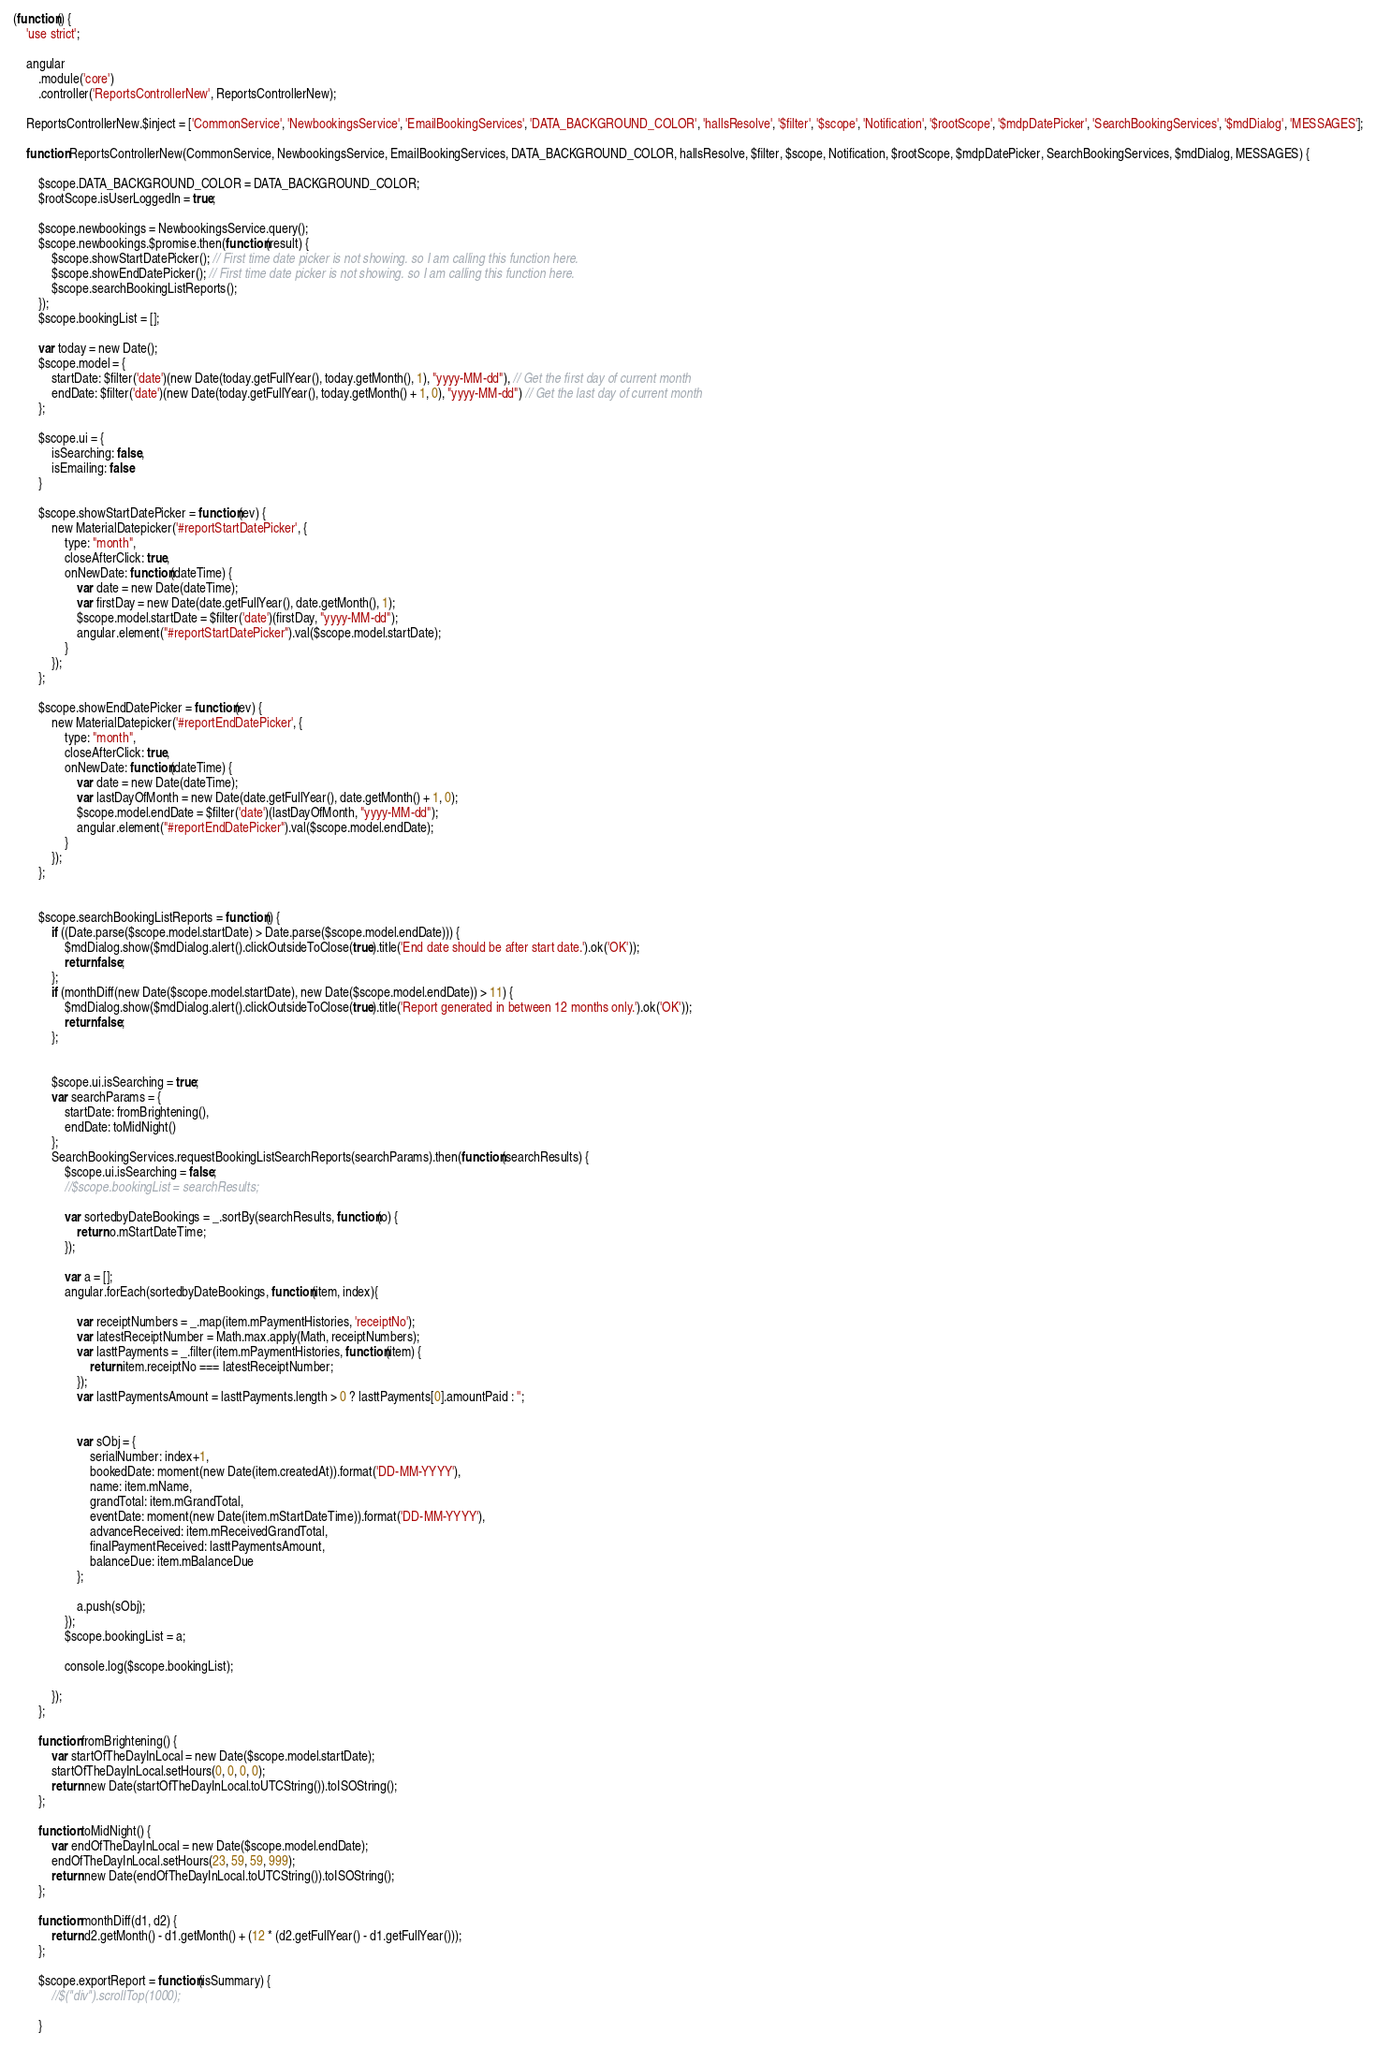<code> <loc_0><loc_0><loc_500><loc_500><_JavaScript_>(function() {
	'use strict';

	angular
		.module('core')
		.controller('ReportsControllerNew', ReportsControllerNew);

	ReportsControllerNew.$inject = ['CommonService', 'NewbookingsService', 'EmailBookingServices', 'DATA_BACKGROUND_COLOR', 'hallsResolve', '$filter', '$scope', 'Notification', '$rootScope', '$mdpDatePicker', 'SearchBookingServices', '$mdDialog', 'MESSAGES'];

	function ReportsControllerNew(CommonService, NewbookingsService, EmailBookingServices, DATA_BACKGROUND_COLOR, hallsResolve, $filter, $scope, Notification, $rootScope, $mdpDatePicker, SearchBookingServices, $mdDialog, MESSAGES) {

		$scope.DATA_BACKGROUND_COLOR = DATA_BACKGROUND_COLOR;
		$rootScope.isUserLoggedIn = true;

		$scope.newbookings = NewbookingsService.query();
		$scope.newbookings.$promise.then(function(result) {
			$scope.showStartDatePicker(); // First time date picker is not showing. so I am calling this function here.
			$scope.showEndDatePicker(); // First time date picker is not showing. so I am calling this function here.
			$scope.searchBookingListReports();
		});
		$scope.bookingList = [];

		var today = new Date();
		$scope.model = {
			startDate: $filter('date')(new Date(today.getFullYear(), today.getMonth(), 1), "yyyy-MM-dd"), // Get the first day of current month
			endDate: $filter('date')(new Date(today.getFullYear(), today.getMonth() + 1, 0), "yyyy-MM-dd") // Get the last day of current month			
		};

		$scope.ui = {
			isSearching: false,
			isEmailing: false
		}

		$scope.showStartDatePicker = function(ev) {
			new MaterialDatepicker('#reportStartDatePicker', {
				type: "month",
				closeAfterClick: true,
				onNewDate: function(dateTime) {
					var date = new Date(dateTime);
					var firstDay = new Date(date.getFullYear(), date.getMonth(), 1);
					$scope.model.startDate = $filter('date')(firstDay, "yyyy-MM-dd");
					angular.element("#reportStartDatePicker").val($scope.model.startDate);
				}
			});
		};

		$scope.showEndDatePicker = function(ev) {
			new MaterialDatepicker('#reportEndDatePicker', {
				type: "month",
				closeAfterClick: true,
				onNewDate: function(dateTime) {
					var date = new Date(dateTime);
					var lastDayOfMonth = new Date(date.getFullYear(), date.getMonth() + 1, 0);
					$scope.model.endDate = $filter('date')(lastDayOfMonth, "yyyy-MM-dd");
					angular.element("#reportEndDatePicker").val($scope.model.endDate);
				}
			});
		};


		$scope.searchBookingListReports = function() {
			if ((Date.parse($scope.model.startDate) > Date.parse($scope.model.endDate))) {
				$mdDialog.show($mdDialog.alert().clickOutsideToClose(true).title('End date should be after start date.').ok('OK'));
				return false;
			};
			if (monthDiff(new Date($scope.model.startDate), new Date($scope.model.endDate)) > 11) {
				$mdDialog.show($mdDialog.alert().clickOutsideToClose(true).title('Report generated in between 12 months only.').ok('OK'));
				return false;
			};


			$scope.ui.isSearching = true;
			var searchParams = {
				startDate: fromBrightening(),
				endDate: toMidNight()
			};
			SearchBookingServices.requestBookingListSearchReports(searchParams).then(function(searchResults) {
				$scope.ui.isSearching = false;
				//$scope.bookingList = searchResults;

				var sortedbyDateBookings = _.sortBy(searchResults, function(o) {
					return o.mStartDateTime;
				});

				var a = [];
				angular.forEach(sortedbyDateBookings, function(item, index){

					var receiptNumbers = _.map(item.mPaymentHistories, 'receiptNo');
					var latestReceiptNumber = Math.max.apply(Math, receiptNumbers);
					var lasttPayments = _.filter(item.mPaymentHistories, function(item) {
						return item.receiptNo === latestReceiptNumber;
					});
					var lasttPaymentsAmount = lasttPayments.length > 0 ? lasttPayments[0].amountPaid : '';

					
					var sObj = {
						serialNumber: index+1,
						bookedDate: moment(new Date(item.createdAt)).format('DD-MM-YYYY'),
						name: item.mName,
						grandTotal: item.mGrandTotal,
						eventDate: moment(new Date(item.mStartDateTime)).format('DD-MM-YYYY'),
						advanceReceived: item.mReceivedGrandTotal,
						finalPaymentReceived: lasttPaymentsAmount,
						balanceDue: item.mBalanceDue
					};

					a.push(sObj);
				});
				$scope.bookingList = a;

				console.log($scope.bookingList);

			});
		};

		function fromBrightening() {
			var startOfTheDayInLocal = new Date($scope.model.startDate);
			startOfTheDayInLocal.setHours(0, 0, 0, 0);
			return new Date(startOfTheDayInLocal.toUTCString()).toISOString();
		};

		function toMidNight() {
			var endOfTheDayInLocal = new Date($scope.model.endDate);
			endOfTheDayInLocal.setHours(23, 59, 59, 999);
			return new Date(endOfTheDayInLocal.toUTCString()).toISOString();
		};

		function monthDiff(d1, d2) {
			return d2.getMonth() - d1.getMonth() + (12 * (d2.getFullYear() - d1.getFullYear()));
		};

		$scope.exportReport = function(isSummary) {
			//$("div").scrollTop(1000);

		}
</code> 